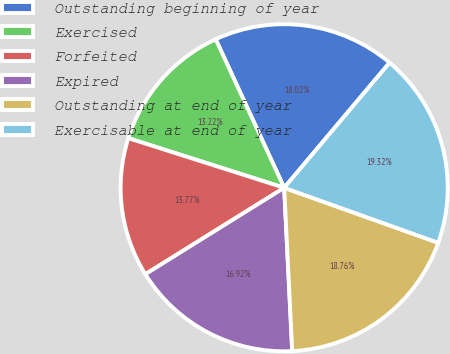Convert chart. <chart><loc_0><loc_0><loc_500><loc_500><pie_chart><fcel>Outstanding beginning of year<fcel>Exercised<fcel>Forfeited<fcel>Expired<fcel>Outstanding at end of year<fcel>Exercisable at end of year<nl><fcel>18.02%<fcel>13.22%<fcel>13.77%<fcel>16.92%<fcel>18.76%<fcel>19.32%<nl></chart> 